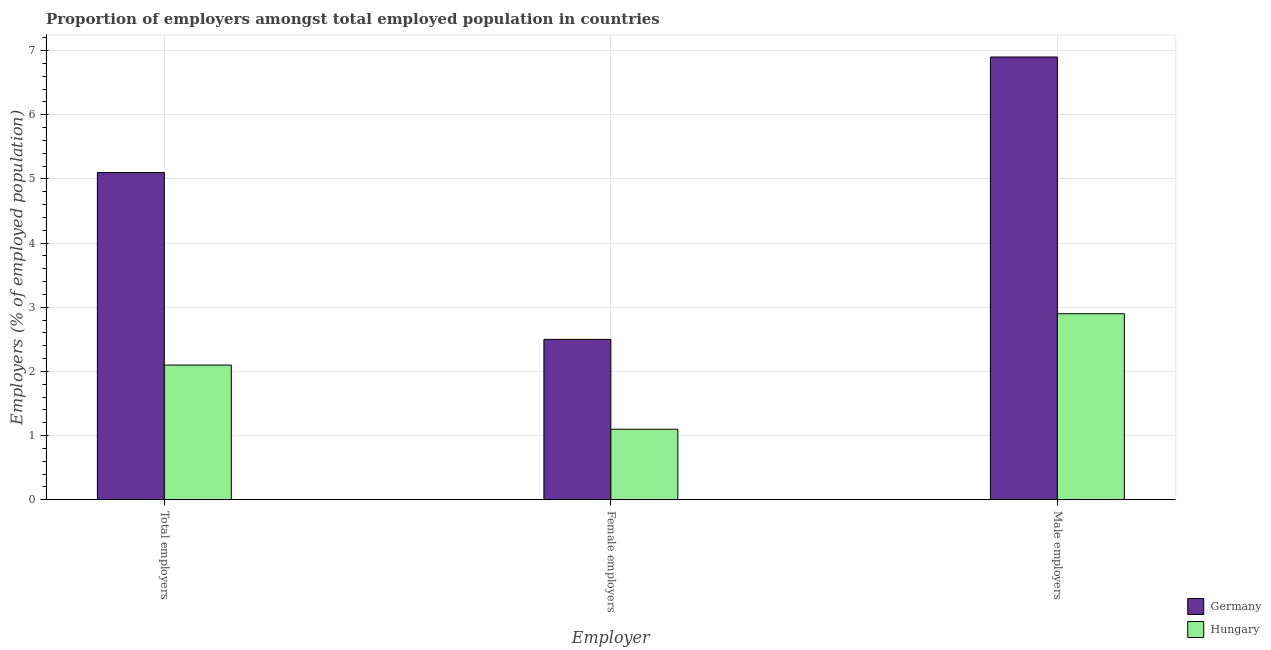How many groups of bars are there?
Provide a succinct answer. 3. Are the number of bars per tick equal to the number of legend labels?
Provide a short and direct response. Yes. How many bars are there on the 1st tick from the left?
Your response must be concise. 2. How many bars are there on the 2nd tick from the right?
Keep it short and to the point. 2. What is the label of the 2nd group of bars from the left?
Offer a terse response. Female employers. What is the percentage of male employers in Germany?
Offer a very short reply. 6.9. Across all countries, what is the maximum percentage of male employers?
Provide a succinct answer. 6.9. Across all countries, what is the minimum percentage of male employers?
Your response must be concise. 2.9. In which country was the percentage of total employers maximum?
Ensure brevity in your answer.  Germany. In which country was the percentage of male employers minimum?
Your answer should be compact. Hungary. What is the total percentage of male employers in the graph?
Offer a terse response. 9.8. What is the difference between the percentage of female employers in Germany and that in Hungary?
Keep it short and to the point. 1.4. What is the difference between the percentage of female employers in Germany and the percentage of male employers in Hungary?
Provide a succinct answer. -0.4. What is the average percentage of female employers per country?
Keep it short and to the point. 1.8. What is the difference between the percentage of female employers and percentage of total employers in Hungary?
Your response must be concise. -1. What is the ratio of the percentage of total employers in Hungary to that in Germany?
Provide a succinct answer. 0.41. Is the percentage of female employers in Hungary less than that in Germany?
Provide a succinct answer. Yes. What is the difference between the highest and the second highest percentage of total employers?
Offer a very short reply. 3. What is the difference between the highest and the lowest percentage of male employers?
Your answer should be compact. 4. In how many countries, is the percentage of male employers greater than the average percentage of male employers taken over all countries?
Keep it short and to the point. 1. What does the 1st bar from the left in Male employers represents?
Provide a short and direct response. Germany. What does the 1st bar from the right in Male employers represents?
Your answer should be compact. Hungary. Is it the case that in every country, the sum of the percentage of total employers and percentage of female employers is greater than the percentage of male employers?
Your answer should be compact. Yes. How many bars are there?
Provide a short and direct response. 6. What is the difference between two consecutive major ticks on the Y-axis?
Your answer should be very brief. 1. Does the graph contain any zero values?
Provide a short and direct response. No. How many legend labels are there?
Keep it short and to the point. 2. How are the legend labels stacked?
Provide a short and direct response. Vertical. What is the title of the graph?
Ensure brevity in your answer.  Proportion of employers amongst total employed population in countries. What is the label or title of the X-axis?
Ensure brevity in your answer.  Employer. What is the label or title of the Y-axis?
Your response must be concise. Employers (% of employed population). What is the Employers (% of employed population) of Germany in Total employers?
Give a very brief answer. 5.1. What is the Employers (% of employed population) in Hungary in Total employers?
Offer a very short reply. 2.1. What is the Employers (% of employed population) in Germany in Female employers?
Provide a succinct answer. 2.5. What is the Employers (% of employed population) of Hungary in Female employers?
Your answer should be very brief. 1.1. What is the Employers (% of employed population) of Germany in Male employers?
Give a very brief answer. 6.9. What is the Employers (% of employed population) in Hungary in Male employers?
Give a very brief answer. 2.9. Across all Employer, what is the maximum Employers (% of employed population) in Germany?
Provide a succinct answer. 6.9. Across all Employer, what is the maximum Employers (% of employed population) in Hungary?
Make the answer very short. 2.9. Across all Employer, what is the minimum Employers (% of employed population) of Hungary?
Offer a terse response. 1.1. What is the total Employers (% of employed population) of Hungary in the graph?
Give a very brief answer. 6.1. What is the difference between the Employers (% of employed population) of Germany in Total employers and that in Female employers?
Keep it short and to the point. 2.6. What is the difference between the Employers (% of employed population) in Hungary in Total employers and that in Male employers?
Give a very brief answer. -0.8. What is the difference between the Employers (% of employed population) of Hungary in Female employers and that in Male employers?
Give a very brief answer. -1.8. What is the difference between the Employers (% of employed population) of Germany in Total employers and the Employers (% of employed population) of Hungary in Female employers?
Offer a very short reply. 4. What is the average Employers (% of employed population) of Germany per Employer?
Provide a succinct answer. 4.83. What is the average Employers (% of employed population) of Hungary per Employer?
Provide a succinct answer. 2.03. What is the difference between the Employers (% of employed population) in Germany and Employers (% of employed population) in Hungary in Male employers?
Your answer should be very brief. 4. What is the ratio of the Employers (% of employed population) of Germany in Total employers to that in Female employers?
Give a very brief answer. 2.04. What is the ratio of the Employers (% of employed population) of Hungary in Total employers to that in Female employers?
Offer a terse response. 1.91. What is the ratio of the Employers (% of employed population) in Germany in Total employers to that in Male employers?
Your answer should be very brief. 0.74. What is the ratio of the Employers (% of employed population) in Hungary in Total employers to that in Male employers?
Your response must be concise. 0.72. What is the ratio of the Employers (% of employed population) in Germany in Female employers to that in Male employers?
Offer a very short reply. 0.36. What is the ratio of the Employers (% of employed population) in Hungary in Female employers to that in Male employers?
Make the answer very short. 0.38. 